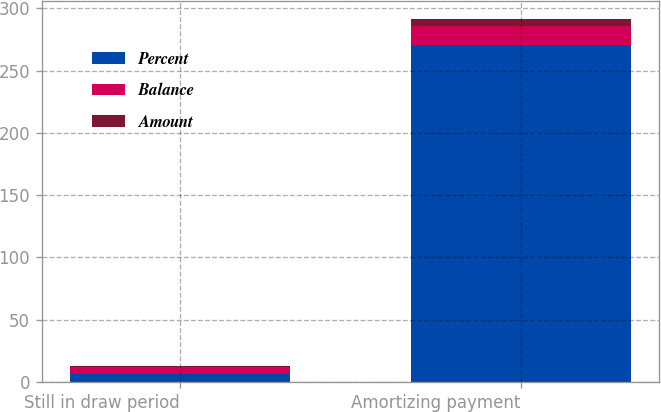Convert chart to OTSL. <chart><loc_0><loc_0><loc_500><loc_500><stacked_bar_chart><ecel><fcel>Still in draw period<fcel>Amortizing payment<nl><fcel>Percent<fcel>6.1<fcel>270.4<nl><fcel>Balance<fcel>6.1<fcel>15.1<nl><fcel>Amount<fcel>0.42<fcel>5.58<nl></chart> 